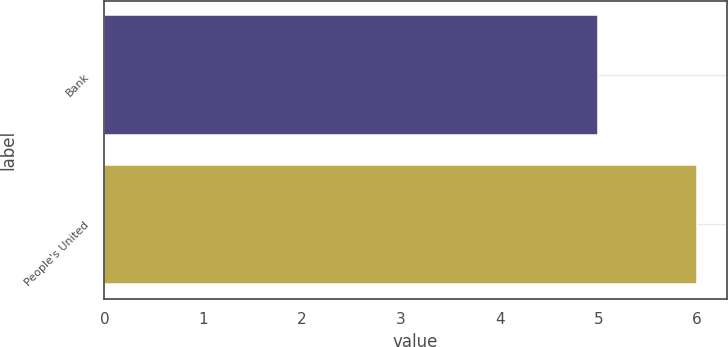<chart> <loc_0><loc_0><loc_500><loc_500><bar_chart><fcel>Bank<fcel>People's United<nl><fcel>5<fcel>6<nl></chart> 